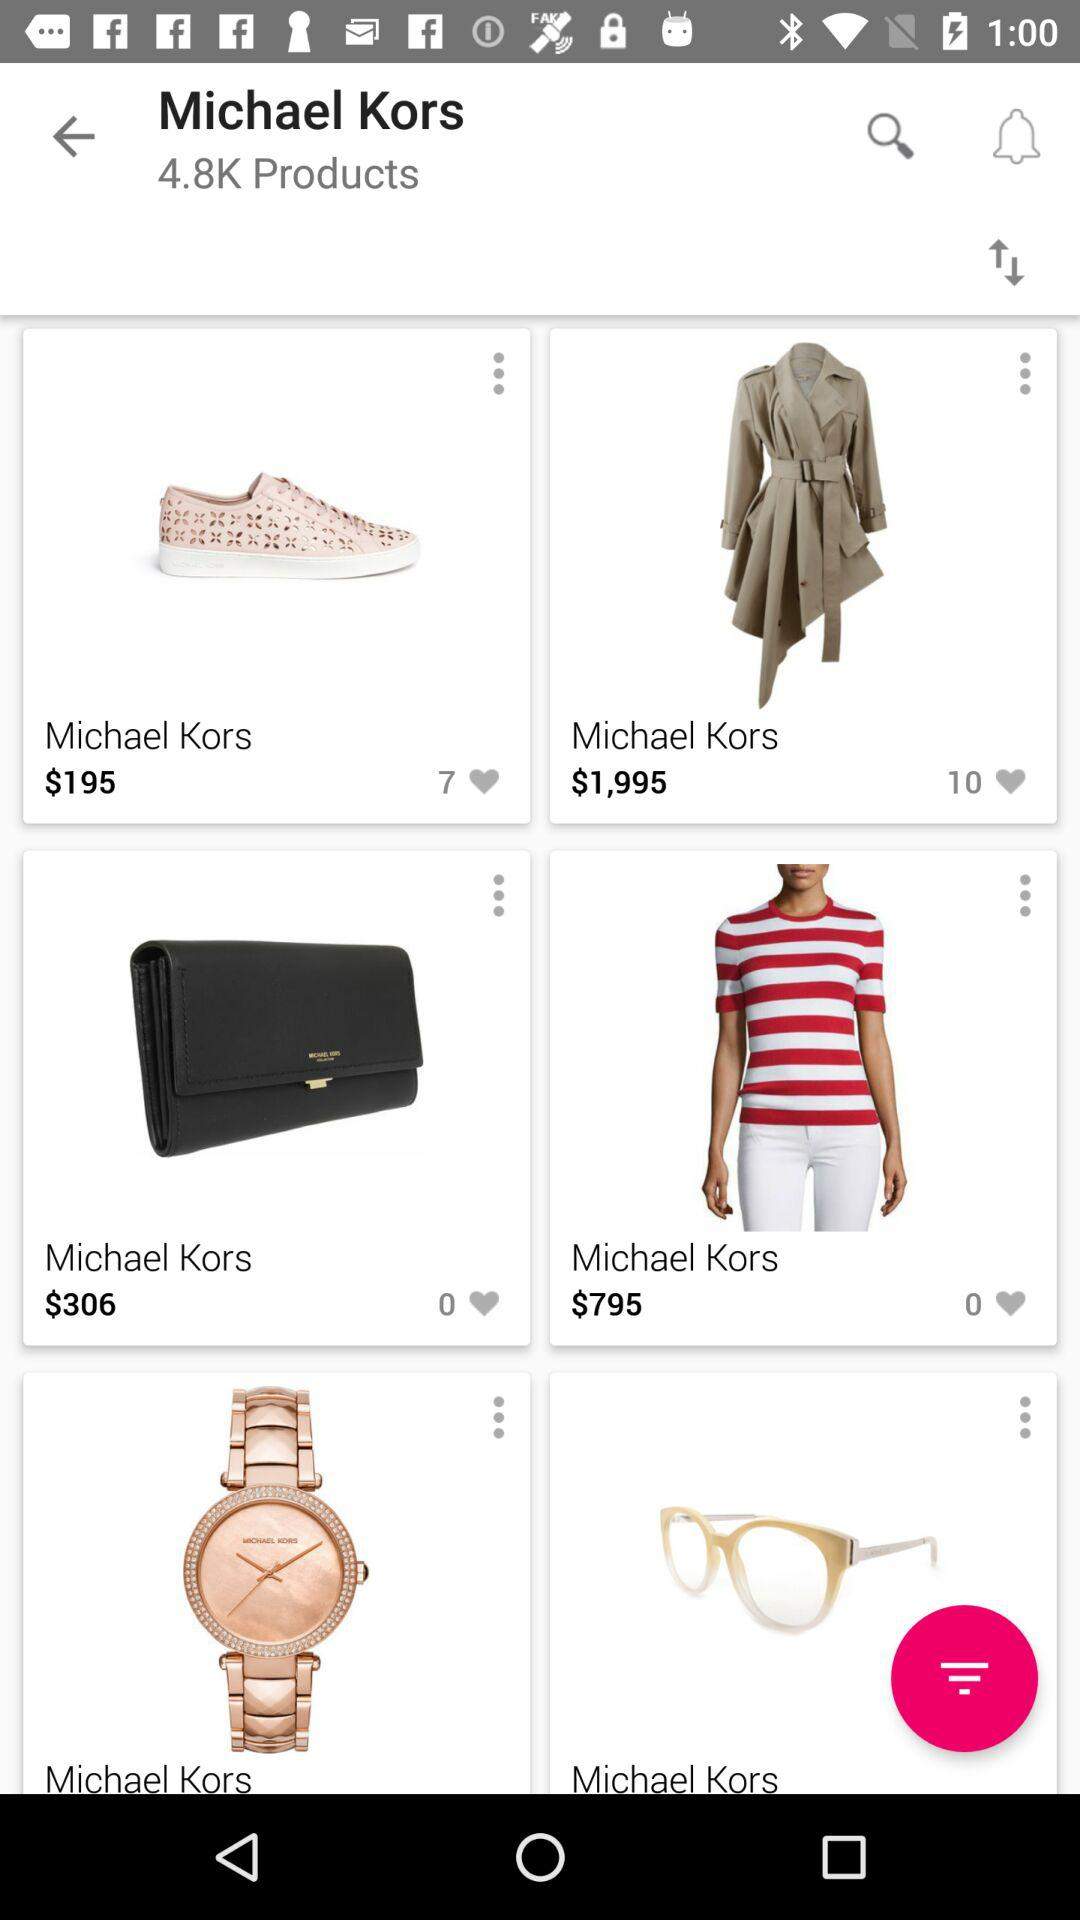How many have liked wallet?
When the provided information is insufficient, respond with <no answer>. <no answer> 